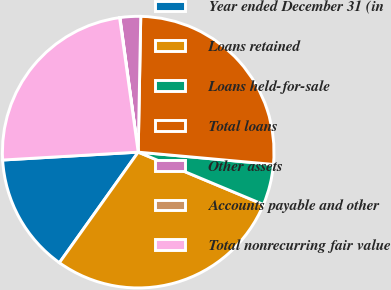Convert chart to OTSL. <chart><loc_0><loc_0><loc_500><loc_500><pie_chart><fcel>Year ended December 31 (in<fcel>Loans retained<fcel>Loans held-for-sale<fcel>Total loans<fcel>Other assets<fcel>Accounts payable and other<fcel>Total nonrecurring fair value<nl><fcel>14.22%<fcel>28.55%<fcel>4.86%<fcel>26.14%<fcel>2.45%<fcel>0.04%<fcel>23.73%<nl></chart> 